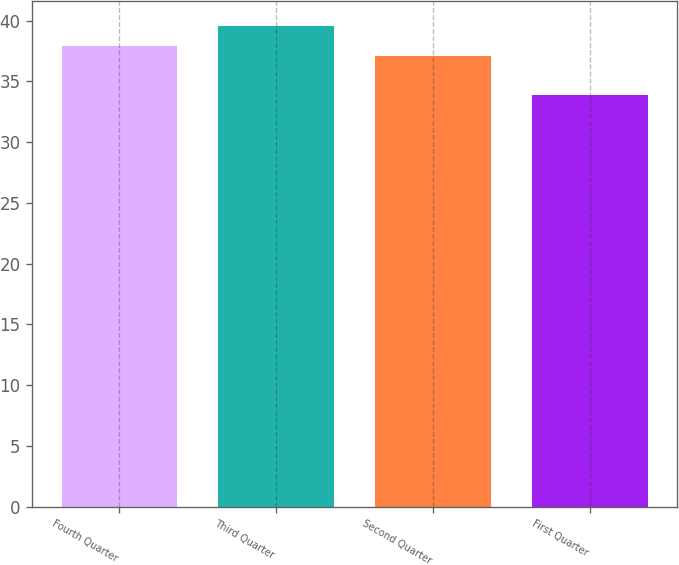Convert chart to OTSL. <chart><loc_0><loc_0><loc_500><loc_500><bar_chart><fcel>Fourth Quarter<fcel>Third Quarter<fcel>Second Quarter<fcel>First Quarter<nl><fcel>37.9<fcel>39.6<fcel>37.12<fcel>33.92<nl></chart> 